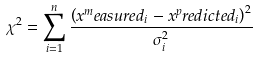<formula> <loc_0><loc_0><loc_500><loc_500>\chi ^ { 2 } = \sum _ { i = 1 } ^ { n } \frac { \left ( x ^ { m } e a s u r e d _ { i } - x ^ { p } r e d i c t e d _ { i } \right ) ^ { 2 } } { \sigma _ { i } ^ { 2 } }</formula> 